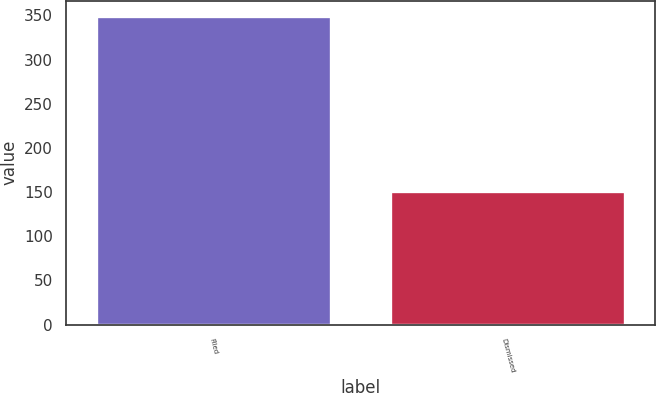Convert chart. <chart><loc_0><loc_0><loc_500><loc_500><bar_chart><fcel>Filed<fcel>Dismissed<nl><fcel>349<fcel>151<nl></chart> 